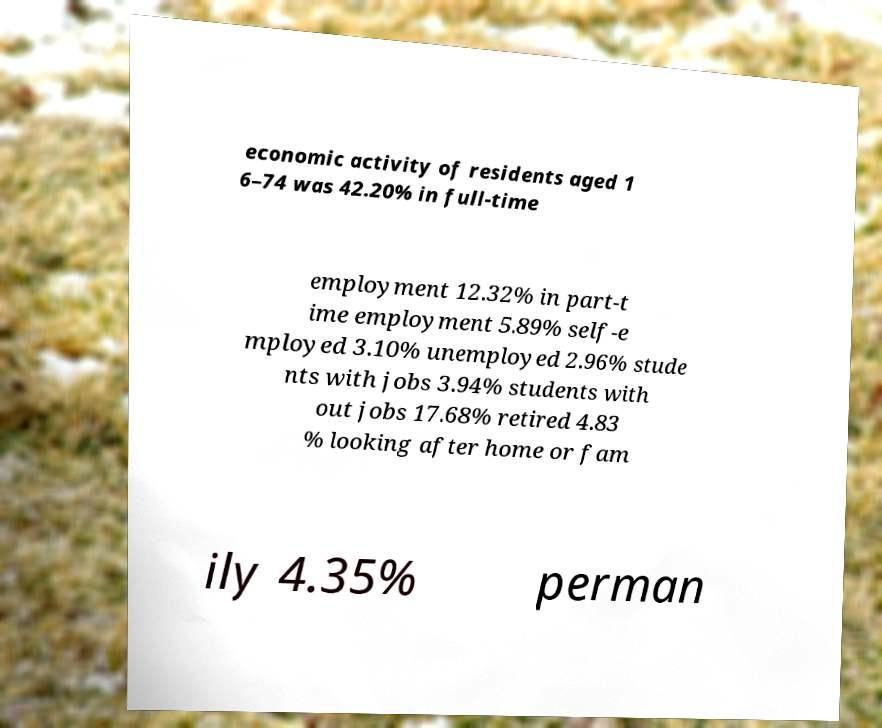For documentation purposes, I need the text within this image transcribed. Could you provide that? economic activity of residents aged 1 6–74 was 42.20% in full-time employment 12.32% in part-t ime employment 5.89% self-e mployed 3.10% unemployed 2.96% stude nts with jobs 3.94% students with out jobs 17.68% retired 4.83 % looking after home or fam ily 4.35% perman 